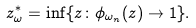<formula> <loc_0><loc_0><loc_500><loc_500>z _ { \omega } ^ { * } = \inf \{ z \colon \phi _ { \omega _ { n } } ( z ) \rightarrow 1 \} .</formula> 